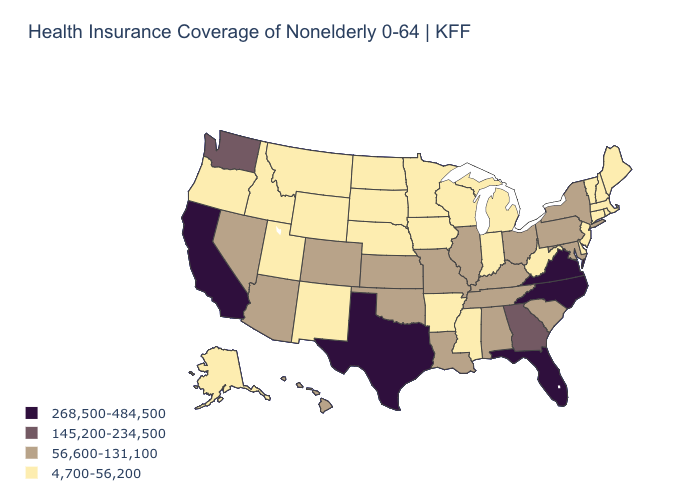What is the lowest value in the South?
Answer briefly. 4,700-56,200. What is the value of Louisiana?
Answer briefly. 56,600-131,100. Name the states that have a value in the range 145,200-234,500?
Quick response, please. Georgia, Washington. How many symbols are there in the legend?
Write a very short answer. 4. Does Illinois have a higher value than Tennessee?
Write a very short answer. No. Does the first symbol in the legend represent the smallest category?
Quick response, please. No. Name the states that have a value in the range 4,700-56,200?
Give a very brief answer. Alaska, Arkansas, Connecticut, Delaware, Idaho, Indiana, Iowa, Maine, Massachusetts, Michigan, Minnesota, Mississippi, Montana, Nebraska, New Hampshire, New Jersey, New Mexico, North Dakota, Oregon, Rhode Island, South Dakota, Utah, Vermont, West Virginia, Wisconsin, Wyoming. What is the highest value in states that border Alabama?
Give a very brief answer. 268,500-484,500. Does Florida have the highest value in the USA?
Answer briefly. Yes. What is the value of Wyoming?
Short answer required. 4,700-56,200. What is the value of North Carolina?
Answer briefly. 268,500-484,500. What is the lowest value in the South?
Be succinct. 4,700-56,200. Does Connecticut have the highest value in the USA?
Short answer required. No. Does Utah have the same value as Mississippi?
Answer briefly. Yes. 